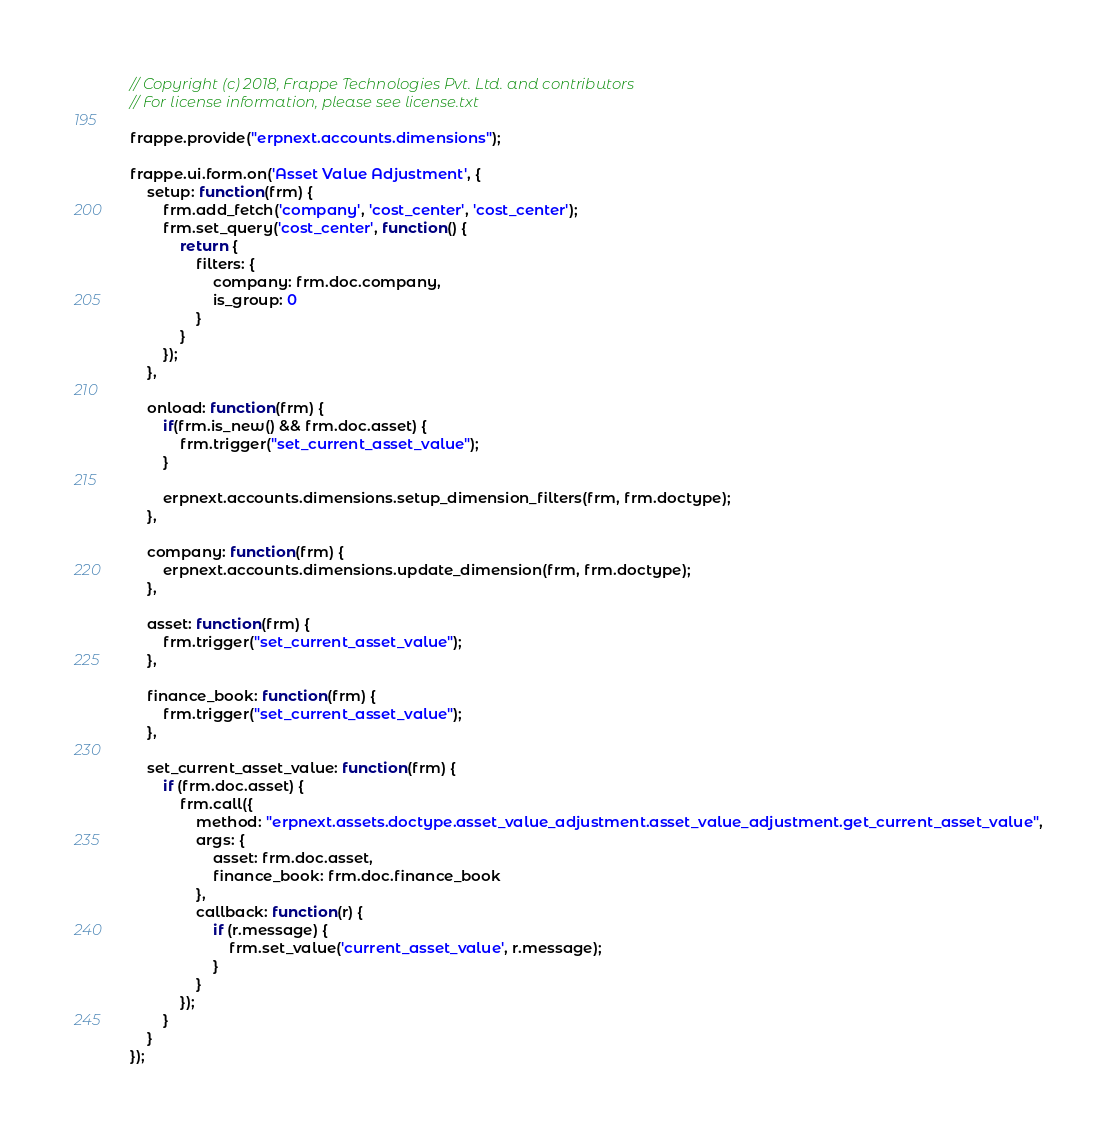<code> <loc_0><loc_0><loc_500><loc_500><_JavaScript_>// Copyright (c) 2018, Frappe Technologies Pvt. Ltd. and contributors
// For license information, please see license.txt

frappe.provide("erpnext.accounts.dimensions");

frappe.ui.form.on('Asset Value Adjustment', {
	setup: function(frm) {
		frm.add_fetch('company', 'cost_center', 'cost_center');
		frm.set_query('cost_center', function() {
			return {
				filters: {
					company: frm.doc.company,
					is_group: 0
				}
			}
		});
	},

	onload: function(frm) {
		if(frm.is_new() && frm.doc.asset) {
			frm.trigger("set_current_asset_value");
		}

		erpnext.accounts.dimensions.setup_dimension_filters(frm, frm.doctype);
	},

	company: function(frm) {
		erpnext.accounts.dimensions.update_dimension(frm, frm.doctype);
	},

	asset: function(frm) {
		frm.trigger("set_current_asset_value");
	},

	finance_book: function(frm) {
		frm.trigger("set_current_asset_value");
	},

	set_current_asset_value: function(frm) {
		if (frm.doc.asset) {
			frm.call({
				method: "erpnext.assets.doctype.asset_value_adjustment.asset_value_adjustment.get_current_asset_value",
				args: {
					asset: frm.doc.asset,
					finance_book: frm.doc.finance_book
				},
				callback: function(r) {
					if (r.message) {
						frm.set_value('current_asset_value', r.message);
					}
				}
			});
		}
	}
});
</code> 